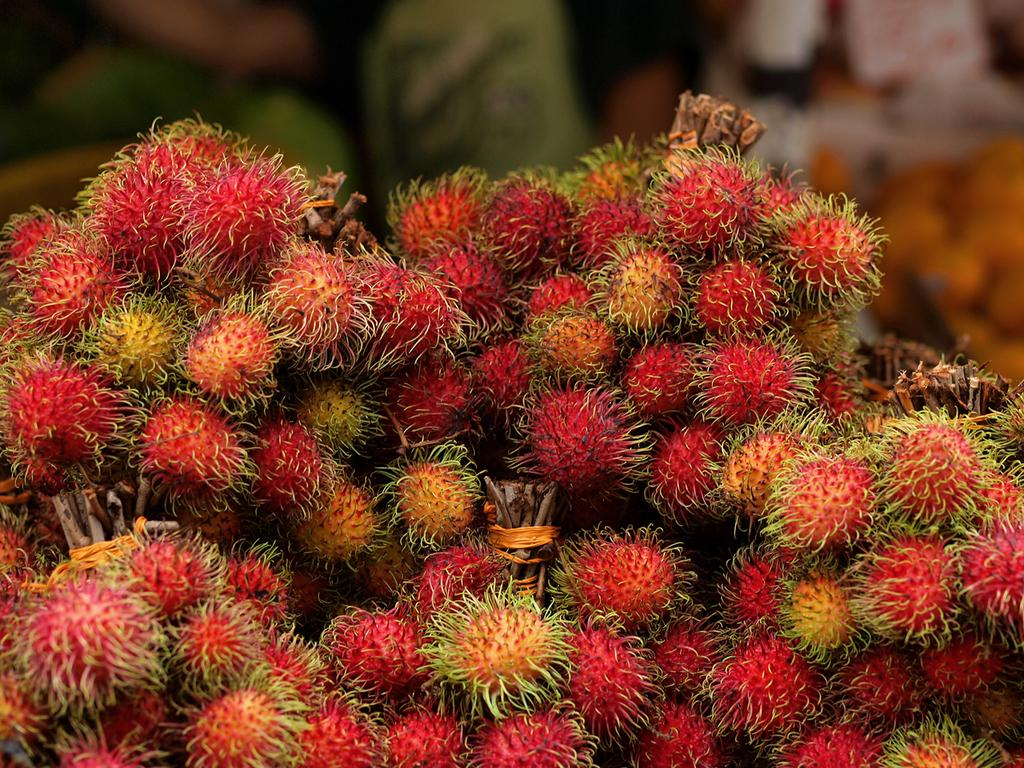What is the main subject of the image? The main subject of the image is a fruit. Can you describe the color of the fruit? The fruit is red in color. What can be observed about the background of the image? The background of the image is blurred. What type of hospital is visible in the background of the image? There is no hospital present in the image; it features a red fruit with a blurred background. What song is being played in the image? There is no indication of any song being played in the image. 